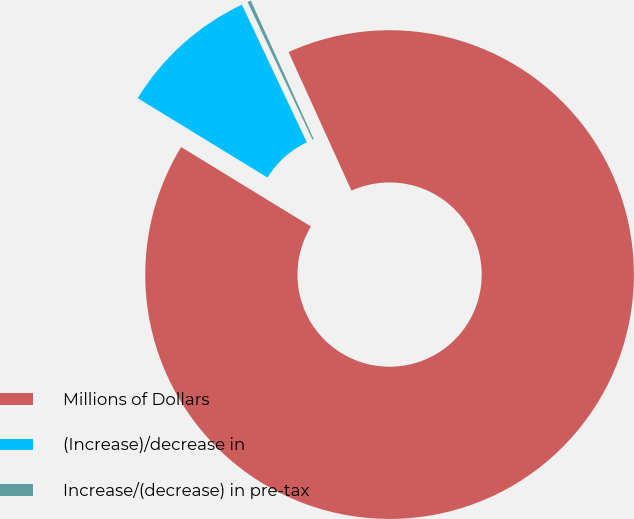<chart> <loc_0><loc_0><loc_500><loc_500><pie_chart><fcel>Millions of Dollars<fcel>(Increase)/decrease in<fcel>Increase/(decrease) in pre-tax<nl><fcel>90.52%<fcel>9.25%<fcel>0.23%<nl></chart> 